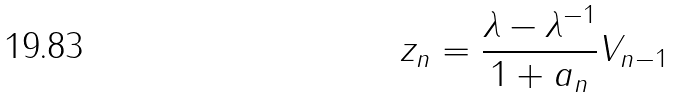<formula> <loc_0><loc_0><loc_500><loc_500>z _ { n } = \frac { \lambda - \lambda ^ { - 1 } } { 1 + a _ { n } } V _ { n - 1 }</formula> 